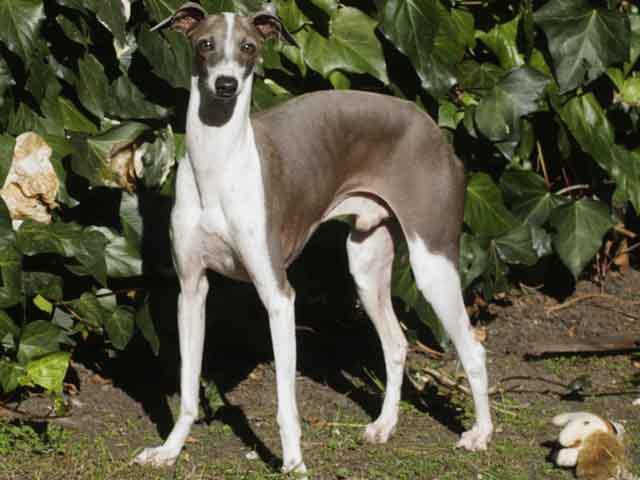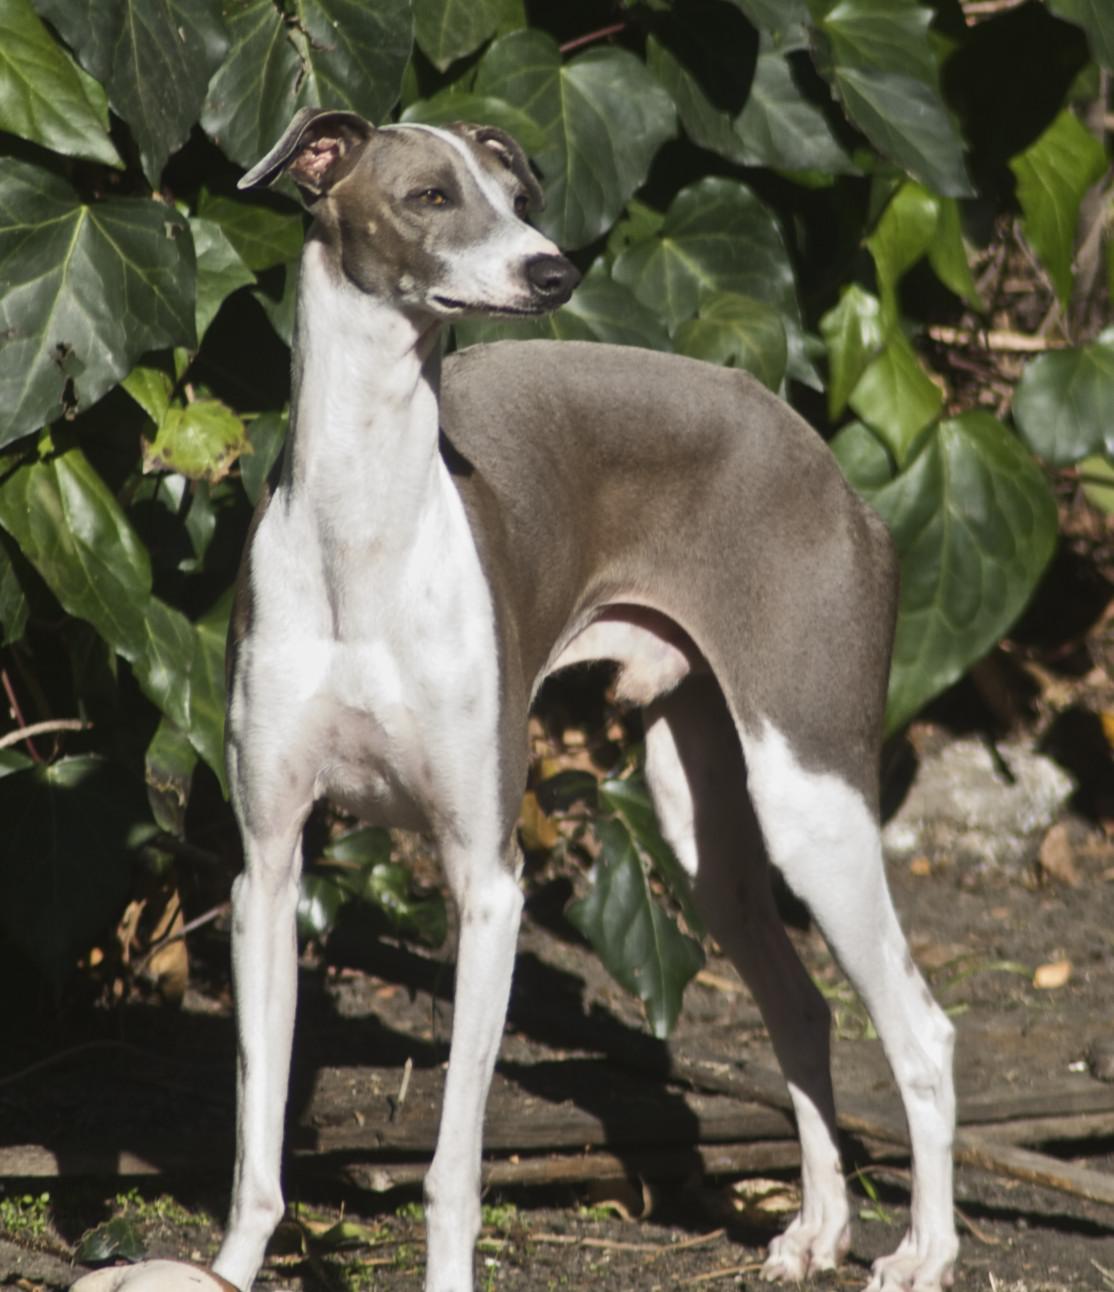The first image is the image on the left, the second image is the image on the right. Given the left and right images, does the statement "There is a plant behind at least one of the dogs." hold true? Answer yes or no. Yes. The first image is the image on the left, the second image is the image on the right. Analyze the images presented: Is the assertion "The right image shows a dog with all four paws on green grass." valid? Answer yes or no. No. 